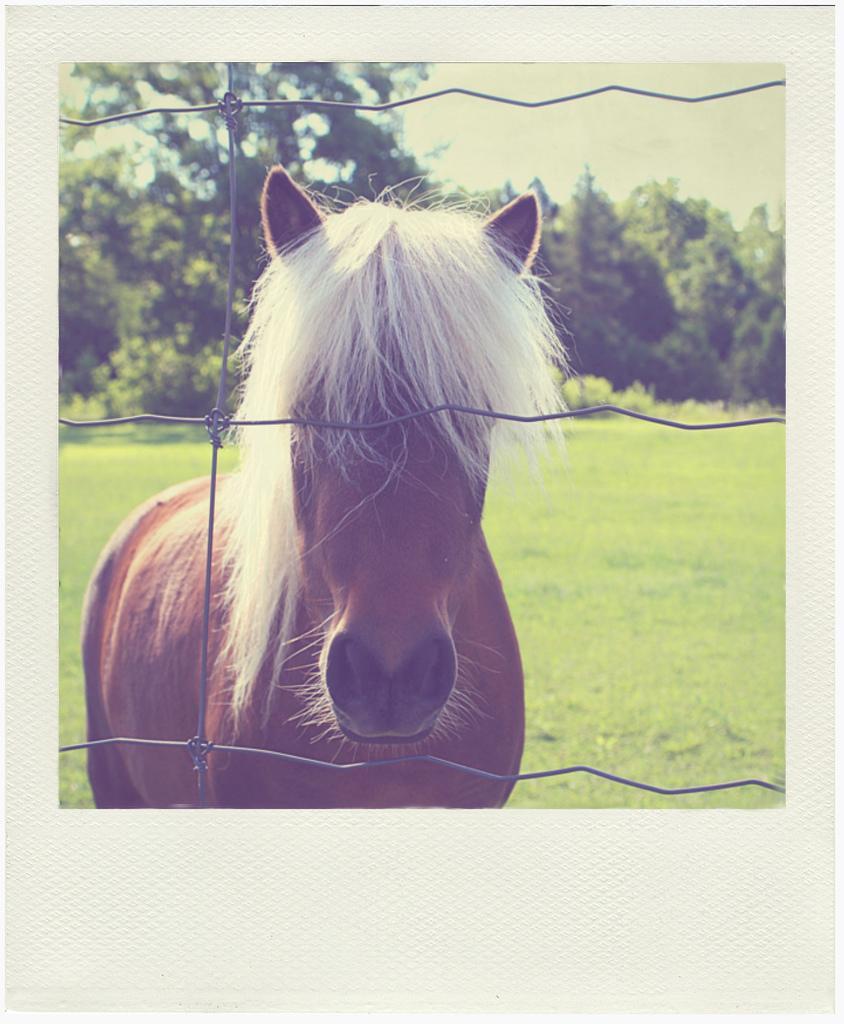Please provide a concise description of this image. This is a horse, it is in brown color. On the back side there are trees. 